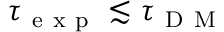<formula> <loc_0><loc_0><loc_500><loc_500>\tau _ { e x p } \lesssim \tau _ { D M }</formula> 